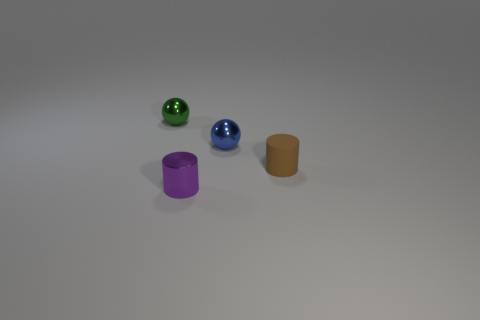Is the material of the small purple cylinder the same as the small sphere on the right side of the tiny purple cylinder? yes 